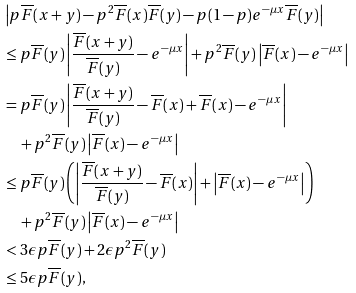<formula> <loc_0><loc_0><loc_500><loc_500>& \left | p \overline { F } ( x + y ) - p ^ { 2 } \overline { F } ( x ) \overline { F } ( y ) - p ( 1 - p ) e ^ { - \mu x } \overline { F } ( y ) \right | \\ & \leq p \overline { F } ( y ) \left | \frac { \overline { F } ( x + y ) } { \overline { F } ( y ) } - e ^ { - \mu x } \right | + p ^ { 2 } \overline { F } ( y ) \left | \overline { F } ( x ) - e ^ { - \mu x } \right | \\ & = p \overline { F } ( y ) \left | \frac { \overline { F } ( x + y ) } { \overline { F } ( y ) } - \overline { F } ( x ) + \overline { F } ( x ) - e ^ { - \mu x } \right | \\ & \quad + p ^ { 2 } \overline { F } ( y ) \left | \overline { F } ( x ) - e ^ { - \mu x } \right | \\ & \leq p \overline { F } ( y ) \left ( \left | \frac { \overline { F } ( x + y ) } { \overline { F } ( y ) } - \overline { F } ( x ) \right | + \left | \overline { F } ( x ) - e ^ { - \mu x } \right | \right ) \\ & \quad + p ^ { 2 } \overline { F } ( y ) \left | \overline { F } ( x ) - e ^ { - \mu x } \right | \\ & < 3 \epsilon p \overline { F } ( y ) + 2 \epsilon p ^ { 2 } \overline { F } ( y ) \\ & \leq 5 \epsilon p \overline { F } ( y ) ,</formula> 